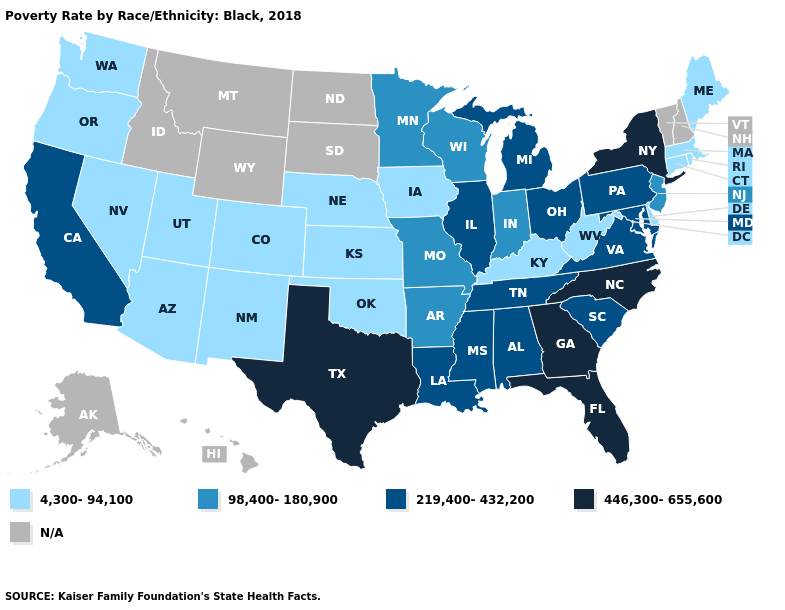What is the lowest value in states that border Wyoming?
Keep it brief. 4,300-94,100. What is the lowest value in the USA?
Quick response, please. 4,300-94,100. What is the value of Pennsylvania?
Keep it brief. 219,400-432,200. What is the highest value in the USA?
Be succinct. 446,300-655,600. What is the lowest value in states that border Illinois?
Concise answer only. 4,300-94,100. What is the lowest value in the MidWest?
Short answer required. 4,300-94,100. Name the states that have a value in the range 219,400-432,200?
Answer briefly. Alabama, California, Illinois, Louisiana, Maryland, Michigan, Mississippi, Ohio, Pennsylvania, South Carolina, Tennessee, Virginia. Name the states that have a value in the range N/A?
Quick response, please. Alaska, Hawaii, Idaho, Montana, New Hampshire, North Dakota, South Dakota, Vermont, Wyoming. Which states have the lowest value in the South?
Concise answer only. Delaware, Kentucky, Oklahoma, West Virginia. Which states hav the highest value in the Northeast?
Keep it brief. New York. Does the map have missing data?
Keep it brief. Yes. Does New York have the highest value in the USA?
Be succinct. Yes. What is the value of Louisiana?
Be succinct. 219,400-432,200. Does New York have the highest value in the Northeast?
Keep it brief. Yes. 